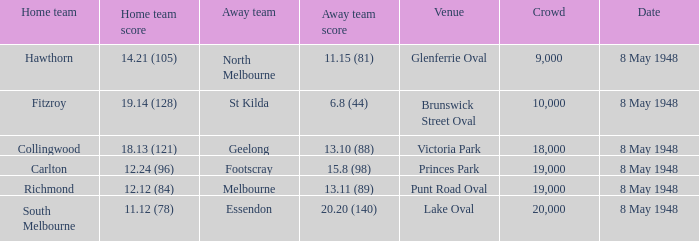21 (105)? North Melbourne. 